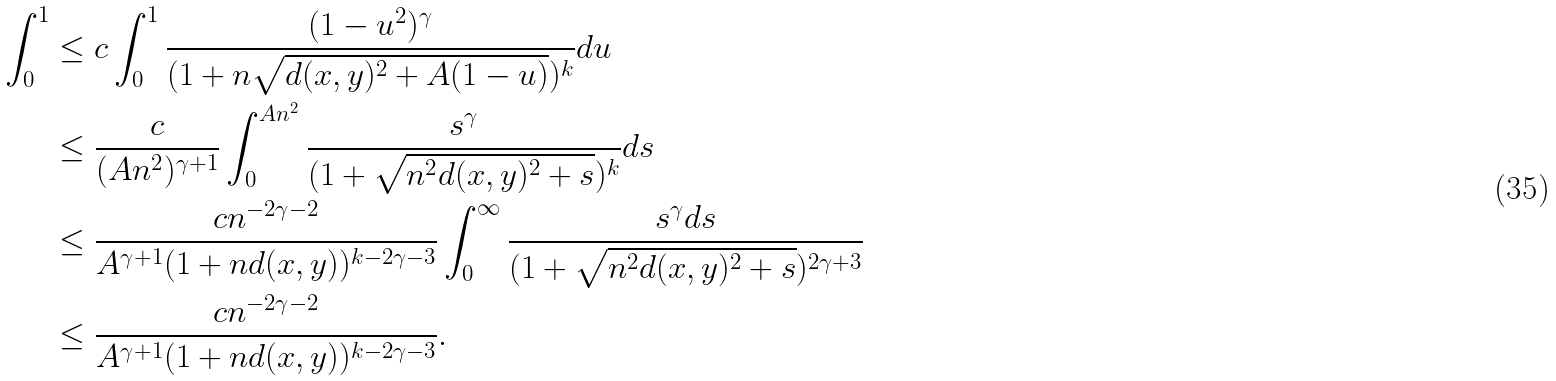Convert formula to latex. <formula><loc_0><loc_0><loc_500><loc_500>\int _ { 0 } ^ { 1 } & \leq c \int _ { 0 } ^ { 1 } \frac { ( 1 - u ^ { 2 } ) ^ { \gamma } } { ( 1 + n \sqrt { d ( x , y ) ^ { 2 } + A ( 1 - u ) } ) ^ { k } } d u \\ & \leq \frac { c } { ( A n ^ { 2 } ) ^ { \gamma + 1 } } \int _ { 0 } ^ { A n ^ { 2 } } \frac { s ^ { \gamma } } { ( 1 + \sqrt { n ^ { 2 } d ( x , y ) ^ { 2 } + s } ) ^ { k } } d s \\ & \leq \frac { c n ^ { - 2 \gamma - 2 } } { A ^ { \gamma + 1 } ( 1 + n d ( x , y ) ) ^ { k - 2 \gamma - 3 } } \int _ { 0 } ^ { \infty } \frac { s ^ { \gamma } d s } { ( 1 + \sqrt { n ^ { 2 } d ( x , y ) ^ { 2 } + s } ) ^ { 2 \gamma + 3 } } \\ & \leq \frac { c n ^ { - 2 \gamma - 2 } } { A ^ { \gamma + 1 } ( 1 + n d ( x , y ) ) ^ { k - 2 \gamma - 3 } } .</formula> 